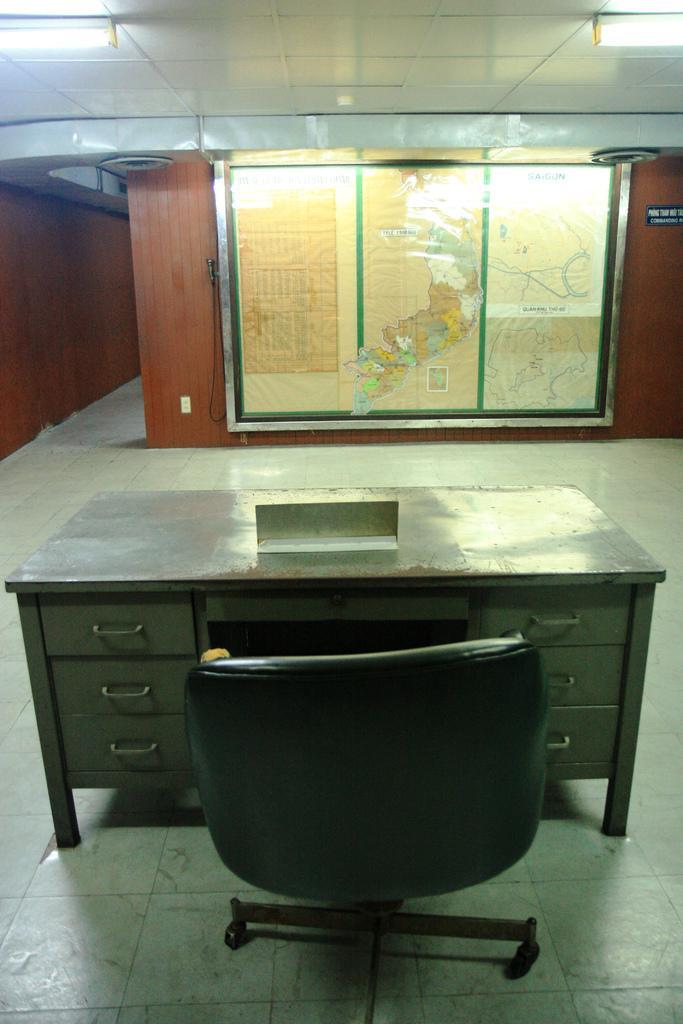In one or two sentences, can you explain what this image depicts? In this picture there is a view of the office Cabin. In the front there is a table and chair. Behind there is a brown color map and beside we can see a wooden panel wall. On the top ceiling there are two tube lights. 